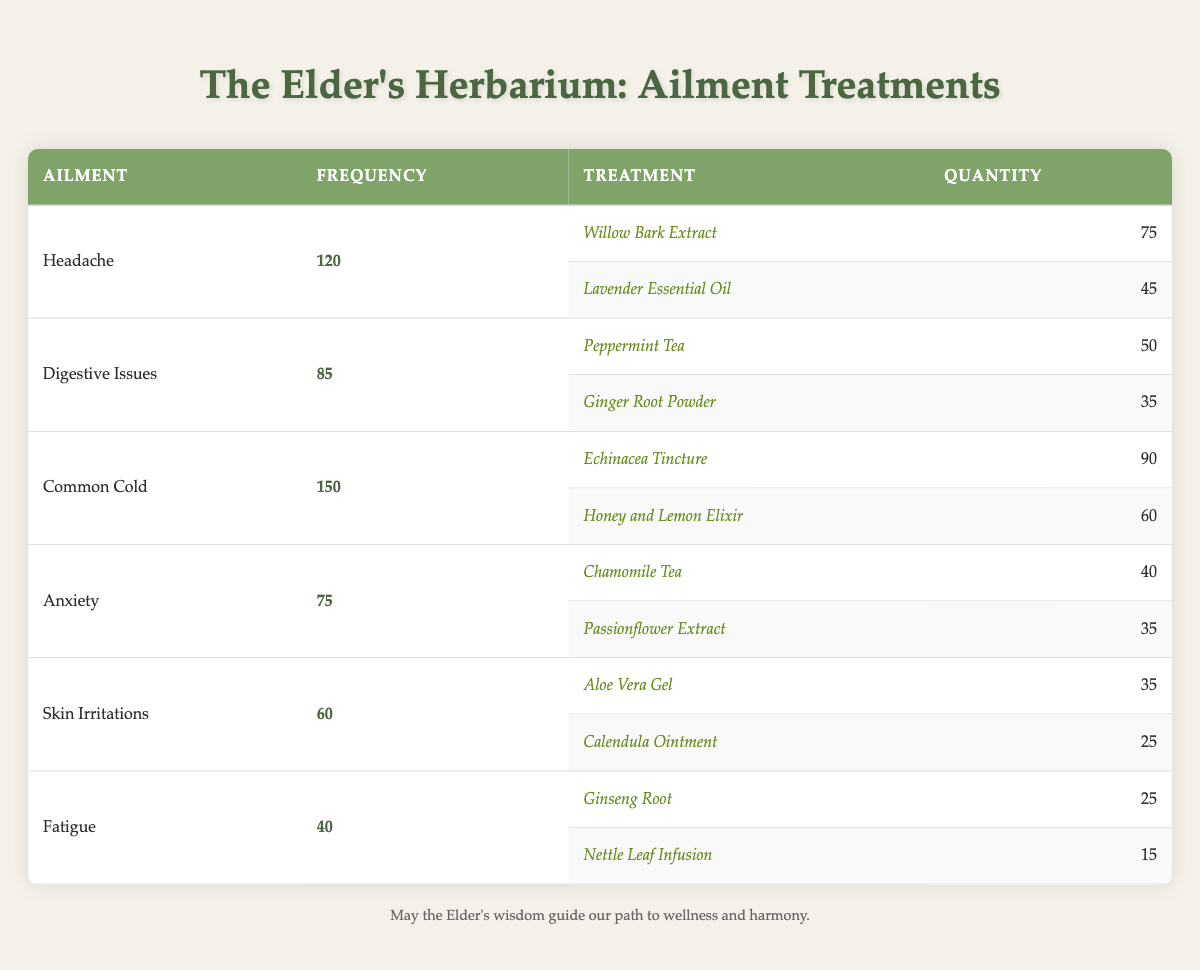What is the most frequently treated ailment at The Elder's Herbarium? The table lists ailments along with their frequencies. By scanning the frequency column, I see that the Common Cold has the highest value at 150.
Answer: Common Cold How many treatments are used for Headache? For Headache, there are two treatments listed: Willow Bark Extract and Lavender Essential Oil.
Answer: 2 What is the total frequency of Digestive Issues and Anxiety combined? Digestive Issues has a frequency of 85 and Anxiety has a frequency of 75. Adding these together: 85 + 75 = 160.
Answer: 160 Which treatment has the highest quantity for skin irritations? The Skin Irritations section shows two treatments: Aloe Vera Gel with a quantity of 35 and Calendula Ointment with a quantity of 25. The highest quantity is for Aloe Vera Gel.
Answer: Aloe Vera Gel Is the quantity of Honey and Lemon Elixir greater than that of Ginseng Root? Honey and Lemon Elixir has a quantity of 60, while Ginseng Root has a quantity of 25. Since 60 > 25, the statement is true.
Answer: Yes What is the average frequency of all ailments treated? The total frequency for all ailments is 120 (Headache) + 85 (Digestive Issues) + 150 (Common Cold) + 75 (Anxiety) + 60 (Skin Irritations) + 40 (Fatigue) = 510. There are 6 ailments, so the average is 510/6 = 85.
Answer: 85 Which ailment has the least frequency of treatments given? Looking at the table, Fatigue has the lowest frequency at 40 compared to other ailments.
Answer: Fatigue How many total treatments contain a quantity of less than 30? From the table, only Calendula Ointment (25) and Nettle Leaf Infusion (15) have quantities less than 30. Thus, there are 2 treatments.
Answer: 2 Does Fatigue have any treatments more than 20 in quantity? The treatments for Fatigue are Ginseng Root (25) and Nettle Leaf Infusion (15). Since Ginseng Root is above 20, the statement is true.
Answer: Yes What is the combined quantity of treatments for the Common Cold? The Common Cold has two treatments: Echinacea Tincture (90) and Honey and Lemon Elixir (60). Adding these quantities: 90 + 60 = 150.
Answer: 150 